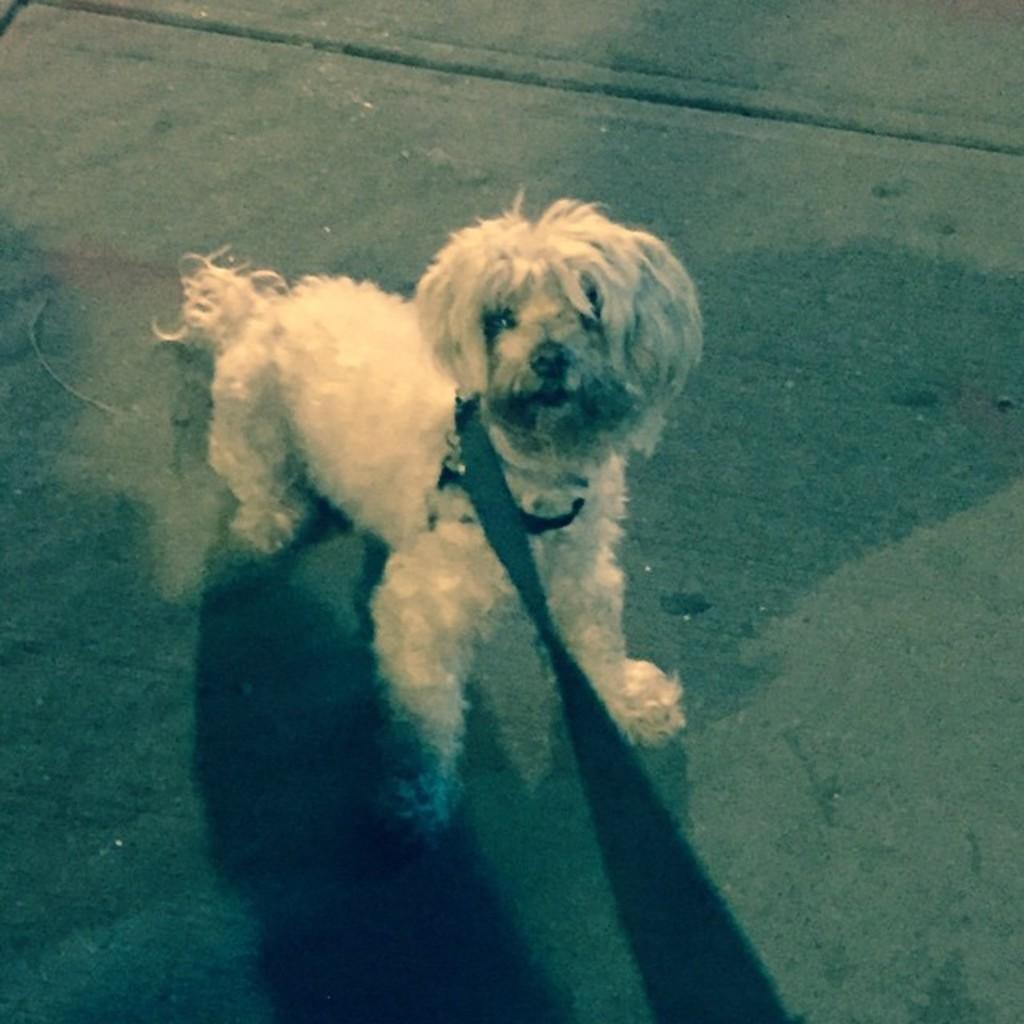What type of animal is in the picture? There is a dog in the picture. Can you describe any accessories the dog is wearing? The dog has a belt around its neck. How does the dog compare to a straw in the picture? There is no straw present in the picture, so it cannot be compared to the dog. 